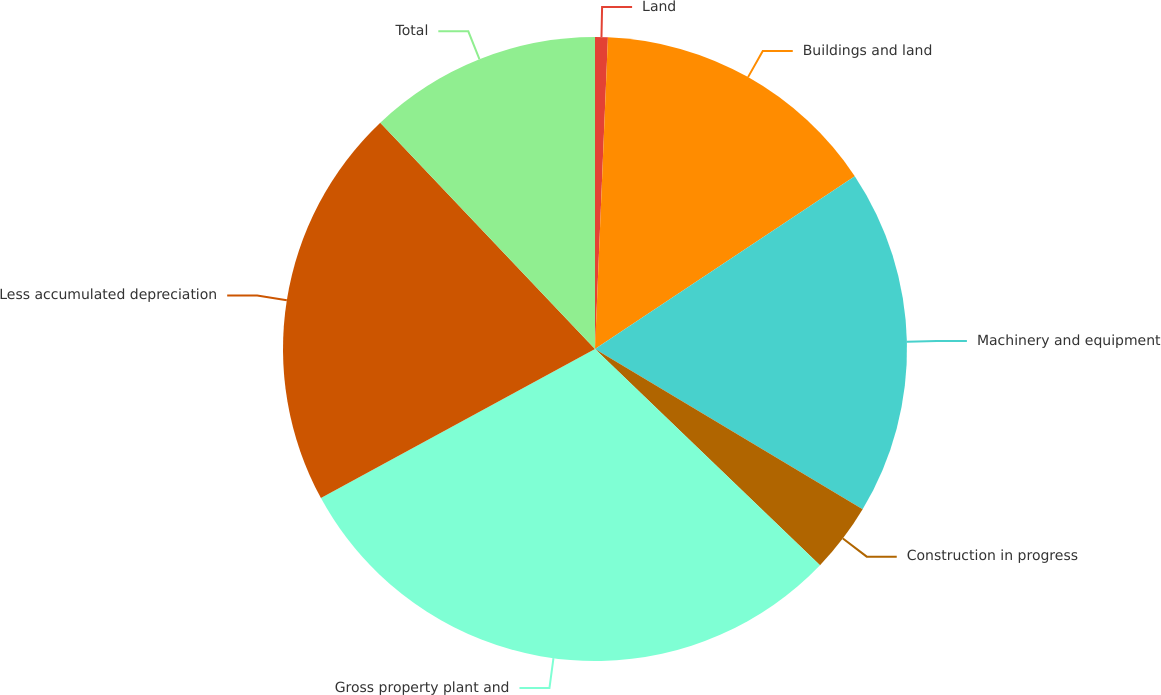<chart> <loc_0><loc_0><loc_500><loc_500><pie_chart><fcel>Land<fcel>Buildings and land<fcel>Machinery and equipment<fcel>Construction in progress<fcel>Gross property plant and<fcel>Less accumulated depreciation<fcel>Total<nl><fcel>0.66%<fcel>15.0%<fcel>17.93%<fcel>3.59%<fcel>29.89%<fcel>20.85%<fcel>12.08%<nl></chart> 